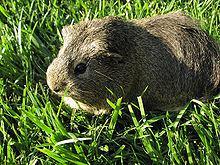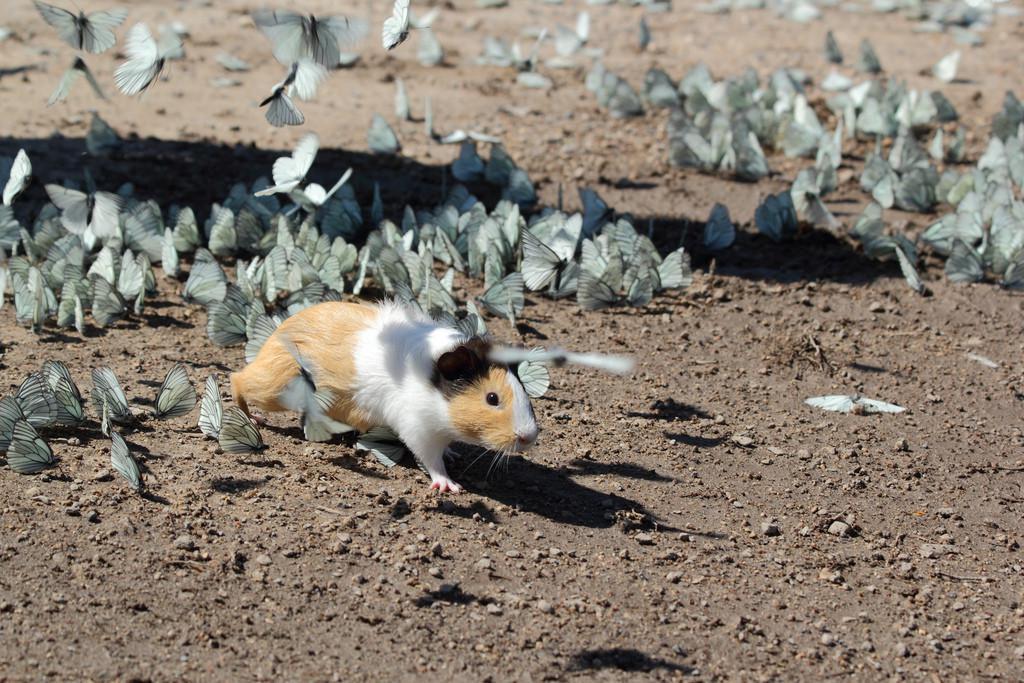The first image is the image on the left, the second image is the image on the right. Evaluate the accuracy of this statement regarding the images: "One of the rodents is sitting still in the green grass.". Is it true? Answer yes or no. Yes. The first image is the image on the left, the second image is the image on the right. Assess this claim about the two images: "An image shows one guinea pig standing in green grass.". Correct or not? Answer yes or no. Yes. 